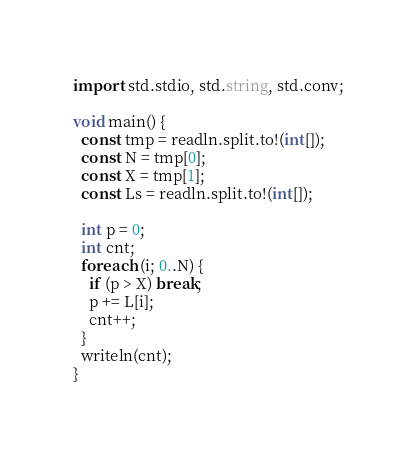<code> <loc_0><loc_0><loc_500><loc_500><_D_>import std.stdio, std.string, std.conv;

void main() {
  const tmp = readln.split.to!(int[]);
  const N = tmp[0];
  const X = tmp[1];
  const Ls = readln.split.to!(int[]);
  
  int p = 0;
  int cnt;
  foreach (i; 0..N) {
    if (p > X) break;
    p += L[i];
    cnt++;
  }
  writeln(cnt);
}</code> 